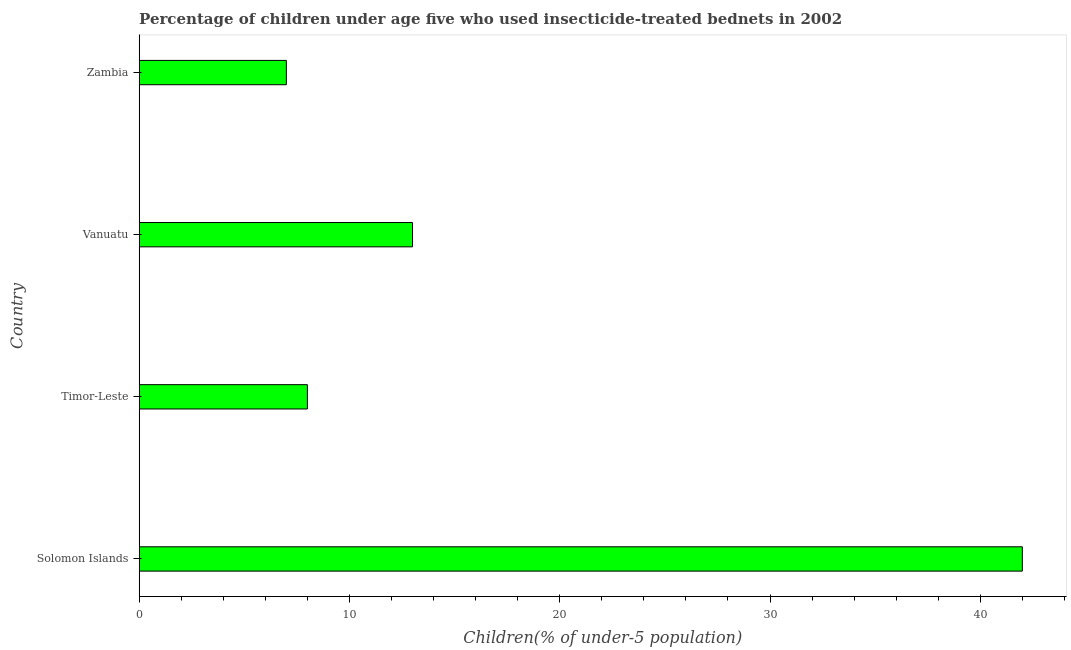What is the title of the graph?
Offer a very short reply. Percentage of children under age five who used insecticide-treated bednets in 2002. What is the label or title of the X-axis?
Offer a very short reply. Children(% of under-5 population). In which country was the percentage of children who use of insecticide-treated bed nets maximum?
Keep it short and to the point. Solomon Islands. In which country was the percentage of children who use of insecticide-treated bed nets minimum?
Make the answer very short. Zambia. What is the median percentage of children who use of insecticide-treated bed nets?
Provide a succinct answer. 10.5. In how many countries, is the percentage of children who use of insecticide-treated bed nets greater than 16 %?
Your response must be concise. 1. What is the ratio of the percentage of children who use of insecticide-treated bed nets in Solomon Islands to that in Vanuatu?
Ensure brevity in your answer.  3.23. Are the values on the major ticks of X-axis written in scientific E-notation?
Offer a very short reply. No. What is the Children(% of under-5 population) in Timor-Leste?
Provide a succinct answer. 8. What is the difference between the Children(% of under-5 population) in Solomon Islands and Timor-Leste?
Make the answer very short. 34. What is the difference between the Children(% of under-5 population) in Solomon Islands and Vanuatu?
Make the answer very short. 29. What is the difference between the Children(% of under-5 population) in Timor-Leste and Vanuatu?
Offer a terse response. -5. What is the ratio of the Children(% of under-5 population) in Solomon Islands to that in Timor-Leste?
Offer a very short reply. 5.25. What is the ratio of the Children(% of under-5 population) in Solomon Islands to that in Vanuatu?
Keep it short and to the point. 3.23. What is the ratio of the Children(% of under-5 population) in Solomon Islands to that in Zambia?
Your response must be concise. 6. What is the ratio of the Children(% of under-5 population) in Timor-Leste to that in Vanuatu?
Your answer should be very brief. 0.61. What is the ratio of the Children(% of under-5 population) in Timor-Leste to that in Zambia?
Offer a terse response. 1.14. What is the ratio of the Children(% of under-5 population) in Vanuatu to that in Zambia?
Provide a short and direct response. 1.86. 